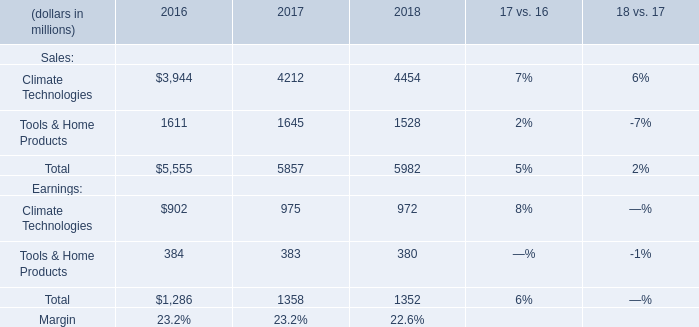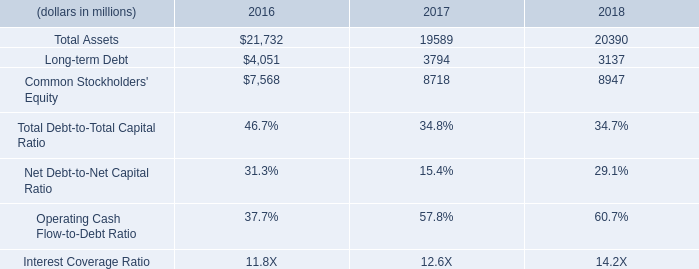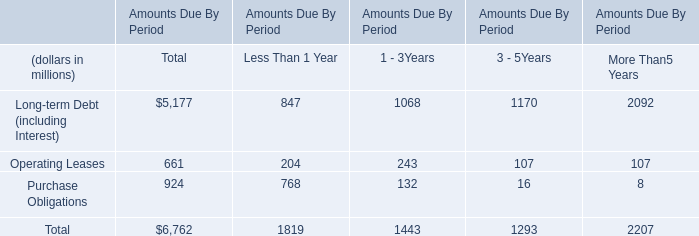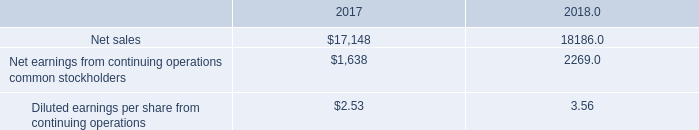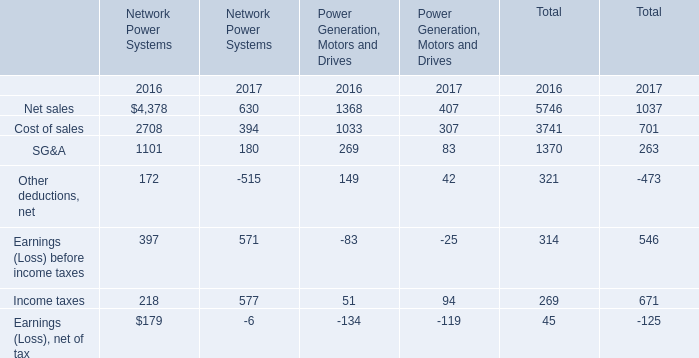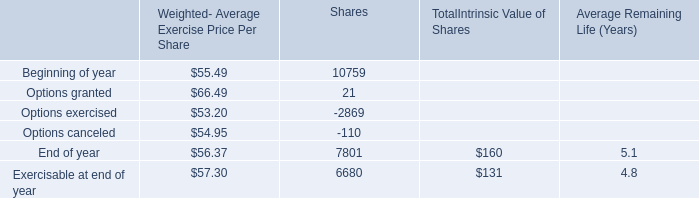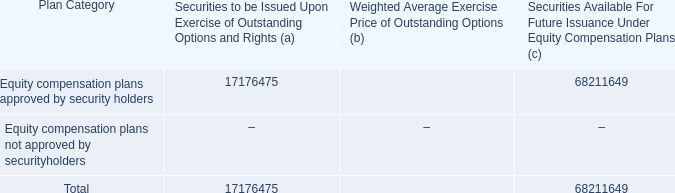In which year is Earnings (Loss) before income taxes smaller than Income taxes ? 
Answer: 2017. 